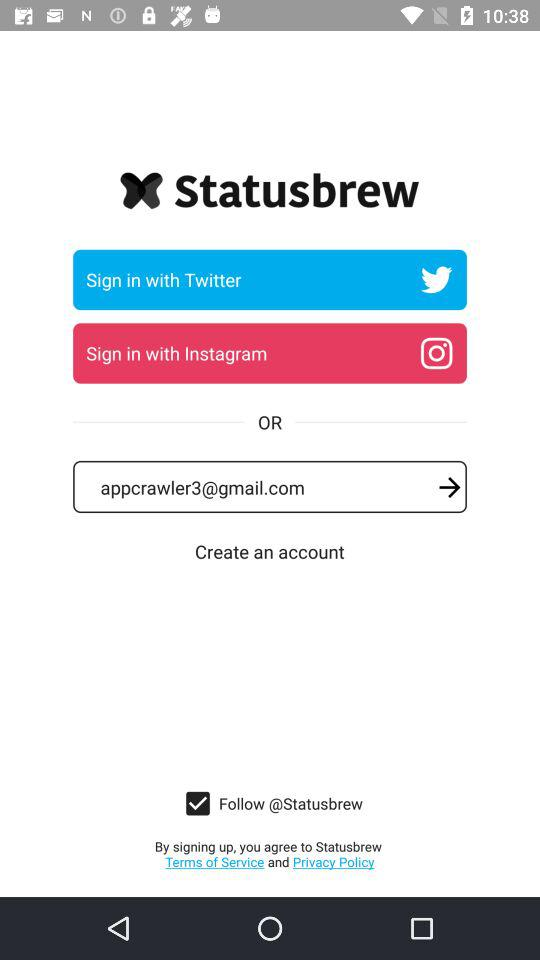Which account are you going to sign in from? You are going to sign in from your "Twitter" or "Instagram" accounts. 